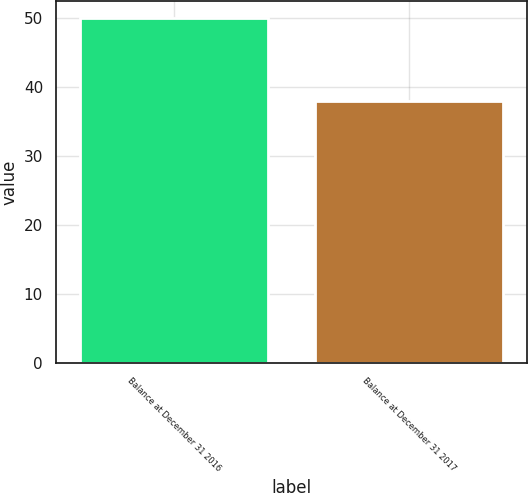<chart> <loc_0><loc_0><loc_500><loc_500><bar_chart><fcel>Balance at December 31 2016<fcel>Balance at December 31 2017<nl><fcel>50<fcel>38<nl></chart> 